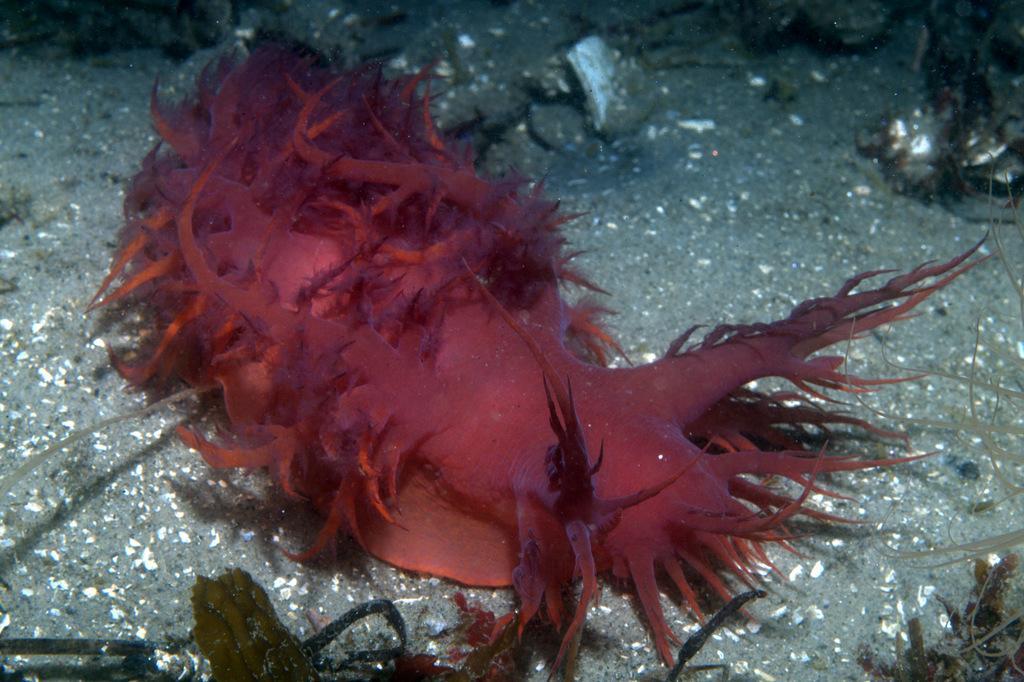Can you describe this image briefly? In this picture we can see a sea slug, this is the picture of underwater environment. 